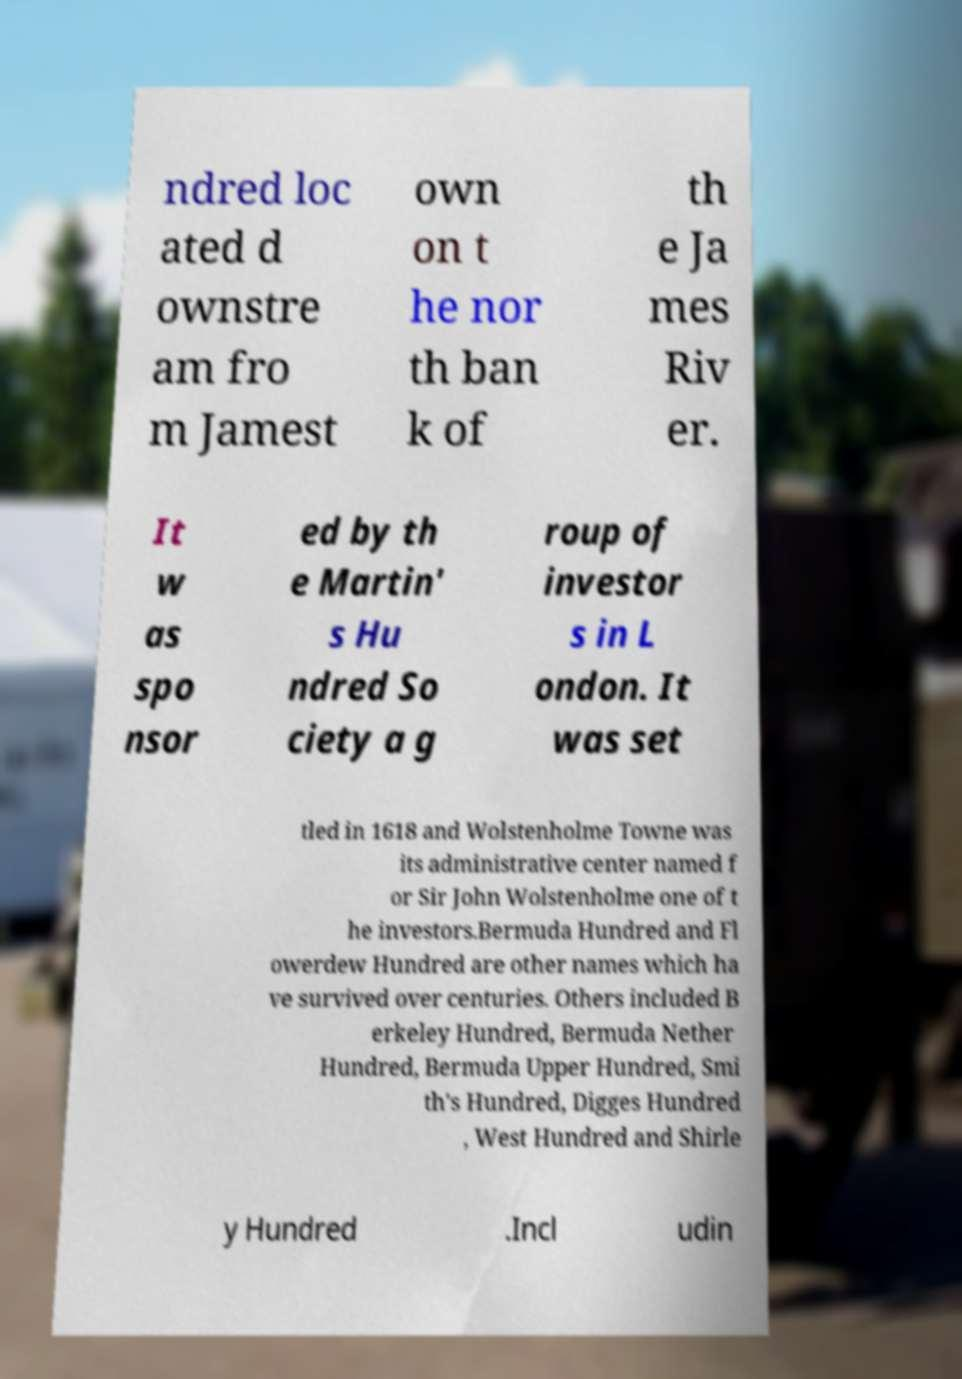Please identify and transcribe the text found in this image. ndred loc ated d ownstre am fro m Jamest own on t he nor th ban k of th e Ja mes Riv er. It w as spo nsor ed by th e Martin' s Hu ndred So ciety a g roup of investor s in L ondon. It was set tled in 1618 and Wolstenholme Towne was its administrative center named f or Sir John Wolstenholme one of t he investors.Bermuda Hundred and Fl owerdew Hundred are other names which ha ve survived over centuries. Others included B erkeley Hundred, Bermuda Nether Hundred, Bermuda Upper Hundred, Smi th's Hundred, Digges Hundred , West Hundred and Shirle y Hundred .Incl udin 